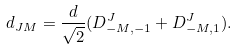Convert formula to latex. <formula><loc_0><loc_0><loc_500><loc_500>d _ { J M } = \frac { d } { \sqrt { 2 } } ( D ^ { J } _ { - M , - 1 } + D ^ { J } _ { - M , 1 } ) .</formula> 